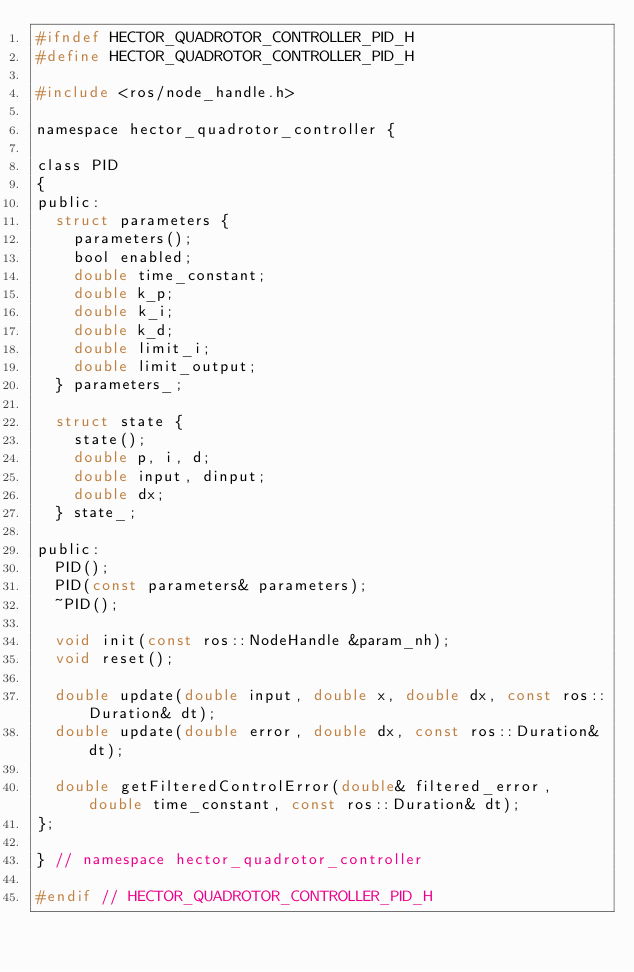<code> <loc_0><loc_0><loc_500><loc_500><_C_>#ifndef HECTOR_QUADROTOR_CONTROLLER_PID_H
#define HECTOR_QUADROTOR_CONTROLLER_PID_H

#include <ros/node_handle.h>

namespace hector_quadrotor_controller {

class PID
{
public:
  struct parameters {
    parameters();
    bool enabled;
    double time_constant;
    double k_p;
    double k_i;
    double k_d;
    double limit_i;
    double limit_output;
  } parameters_;

  struct state {
    state();
    double p, i, d;
    double input, dinput;
    double dx;
  } state_;

public:
  PID();
  PID(const parameters& parameters);
  ~PID();

  void init(const ros::NodeHandle &param_nh);
  void reset();

  double update(double input, double x, double dx, const ros::Duration& dt);
  double update(double error, double dx, const ros::Duration& dt);

  double getFilteredControlError(double& filtered_error, double time_constant, const ros::Duration& dt);
};

} // namespace hector_quadrotor_controller

#endif // HECTOR_QUADROTOR_CONTROLLER_PID_H
</code> 